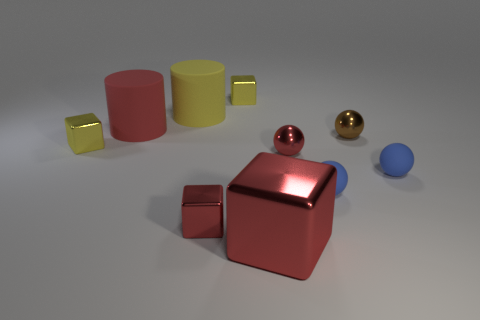Do the large yellow rubber thing and the red matte object have the same shape?
Keep it short and to the point. Yes. What number of yellow blocks are right of the shiny object behind the tiny brown shiny ball?
Provide a short and direct response. 0. There is a big red object that is the same material as the tiny brown thing; what is its shape?
Provide a short and direct response. Cube. How many green objects are either rubber balls or large metallic cubes?
Give a very brief answer. 0. There is a yellow shiny object that is in front of the large red cylinder behind the small red cube; is there a large rubber thing that is in front of it?
Provide a succinct answer. No. Is the number of yellow objects less than the number of brown things?
Keep it short and to the point. No. There is a yellow object that is in front of the small brown thing; is it the same shape as the red rubber object?
Your answer should be very brief. No. Are any big yellow things visible?
Keep it short and to the point. Yes. The shiny block that is to the left of the red thing that is to the left of the red block behind the big shiny block is what color?
Your answer should be compact. Yellow. Is the number of red cylinders in front of the big red rubber thing the same as the number of tiny yellow metallic things to the left of the brown thing?
Your response must be concise. No. 